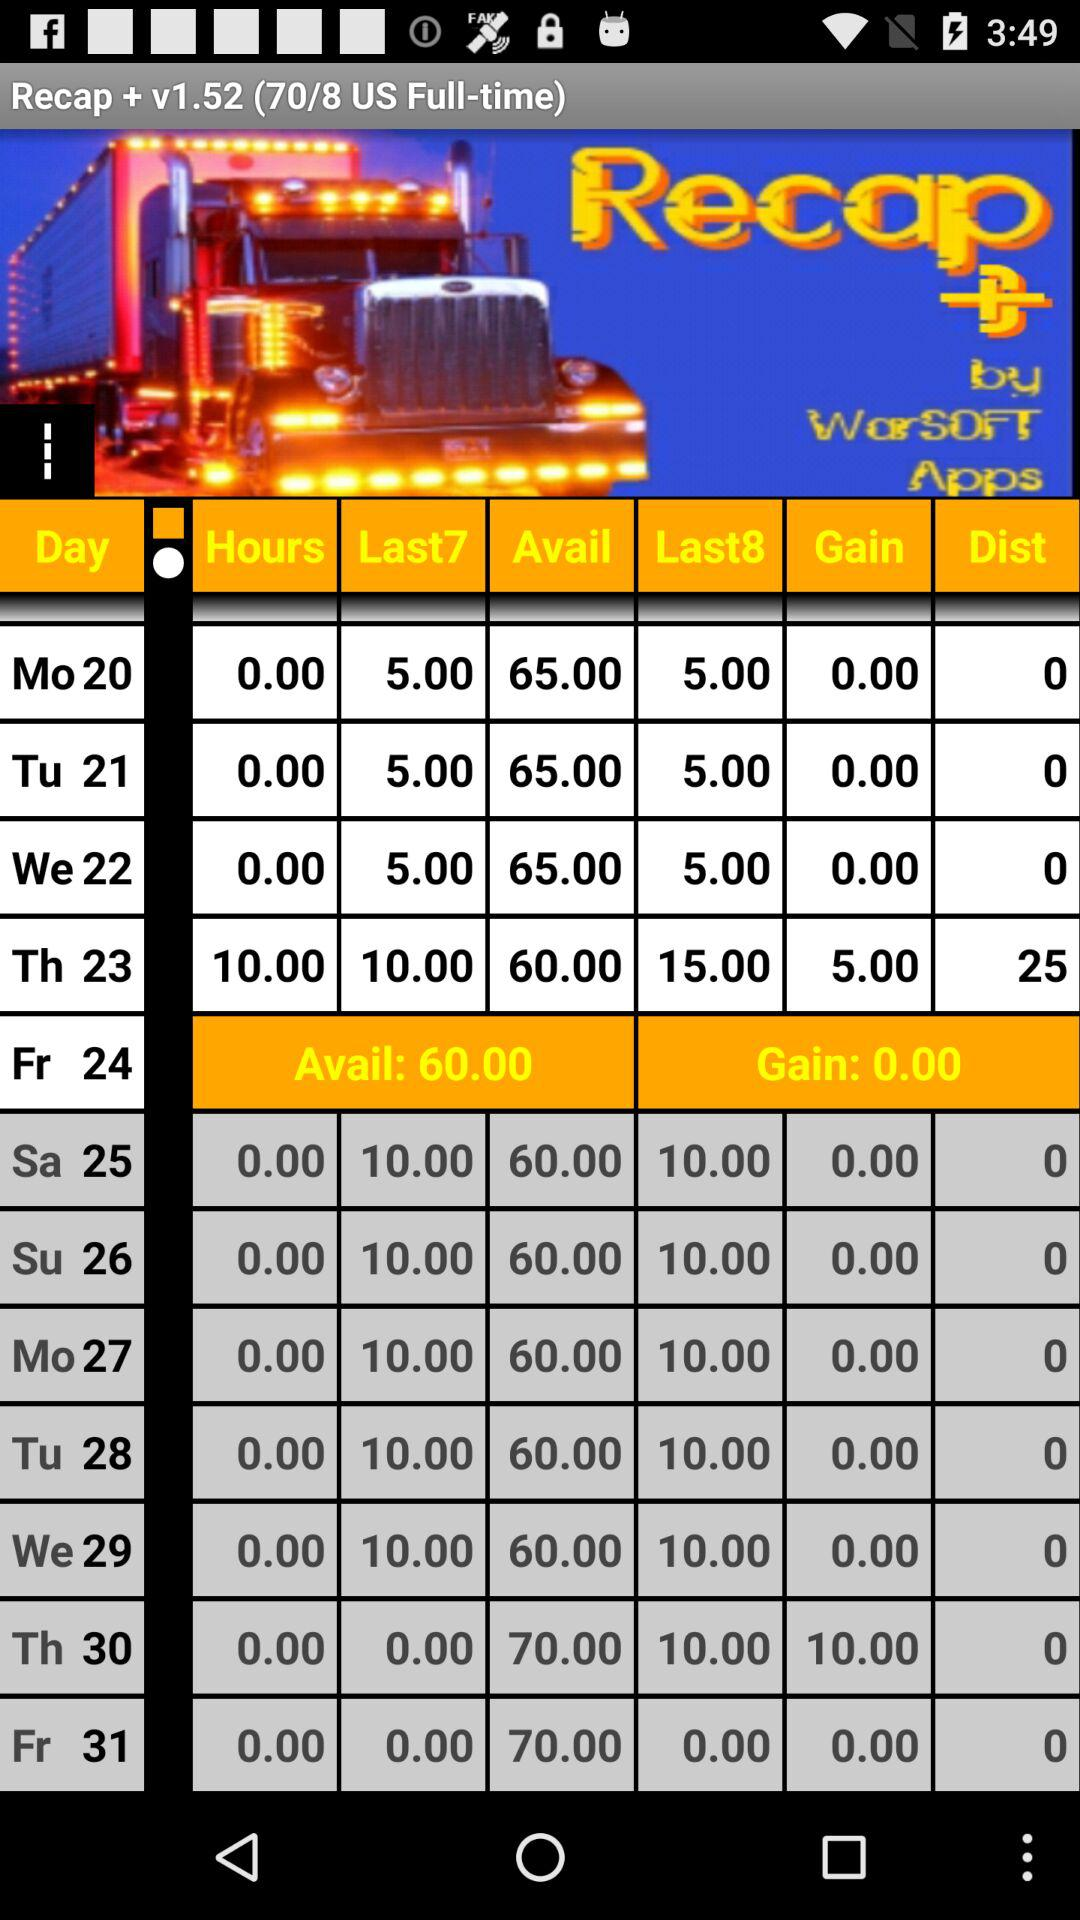What are the available stats on Monday 20?
When the provided information is insufficient, respond with <no answer>. <no answer> 